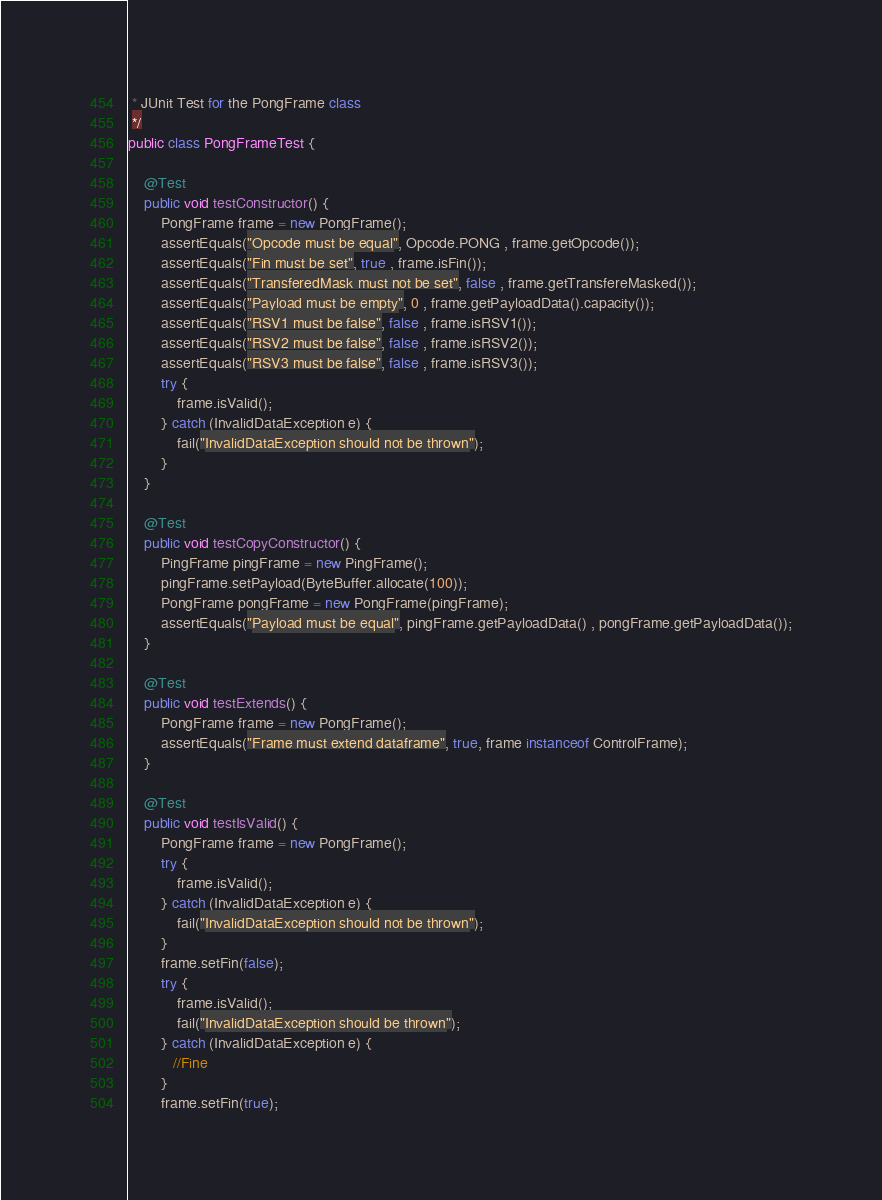<code> <loc_0><loc_0><loc_500><loc_500><_Java_> * JUnit Test for the PongFrame class
 */
public class PongFrameTest {

    @Test
    public void testConstructor() {
        PongFrame frame = new PongFrame();
        assertEquals("Opcode must be equal", Opcode.PONG , frame.getOpcode());
        assertEquals("Fin must be set", true , frame.isFin());
        assertEquals("TransferedMask must not be set", false , frame.getTransfereMasked());
        assertEquals("Payload must be empty", 0 , frame.getPayloadData().capacity());
        assertEquals("RSV1 must be false", false , frame.isRSV1());
        assertEquals("RSV2 must be false", false , frame.isRSV2());
        assertEquals("RSV3 must be false", false , frame.isRSV3());
        try {
            frame.isValid();
        } catch (InvalidDataException e) {
            fail("InvalidDataException should not be thrown");
        }
    }

    @Test
    public void testCopyConstructor() {
        PingFrame pingFrame = new PingFrame();
        pingFrame.setPayload(ByteBuffer.allocate(100));
        PongFrame pongFrame = new PongFrame(pingFrame);
        assertEquals("Payload must be equal", pingFrame.getPayloadData() , pongFrame.getPayloadData());
    }

    @Test
    public void testExtends() {
        PongFrame frame = new PongFrame();
        assertEquals("Frame must extend dataframe", true, frame instanceof ControlFrame);
    }

    @Test
    public void testIsValid() {
        PongFrame frame = new PongFrame();
        try {
            frame.isValid();
        } catch (InvalidDataException e) {
            fail("InvalidDataException should not be thrown");
        }
        frame.setFin(false);
        try {
            frame.isValid();
            fail("InvalidDataException should be thrown");
        } catch (InvalidDataException e) {
           //Fine
        }
        frame.setFin(true);</code> 